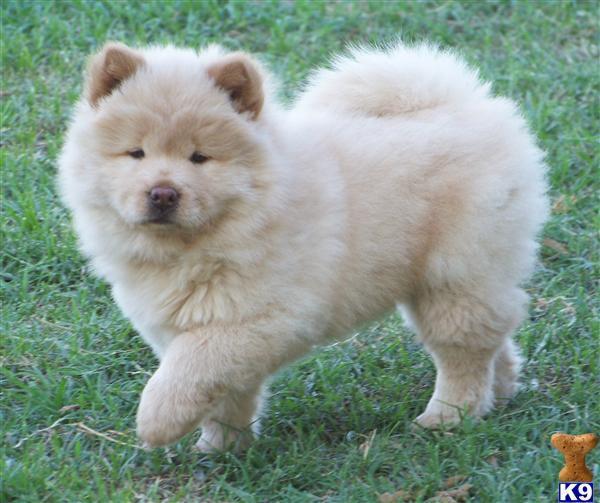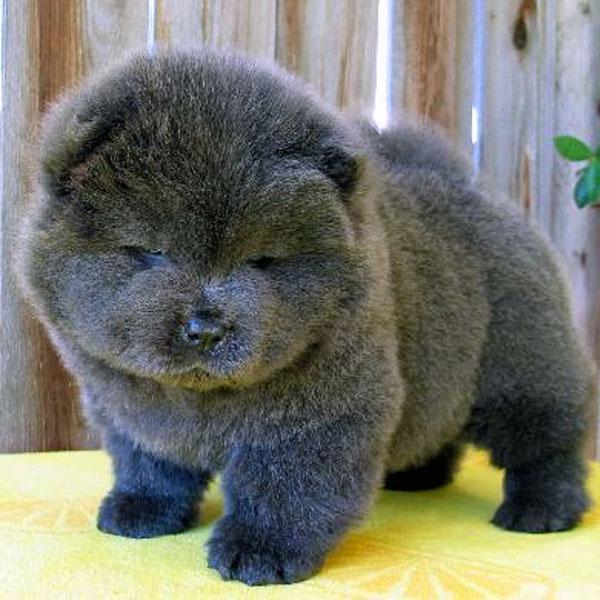The first image is the image on the left, the second image is the image on the right. For the images displayed, is the sentence "Only one dog is not in the grass." factually correct? Answer yes or no. Yes. The first image is the image on the left, the second image is the image on the right. Examine the images to the left and right. Is the description "One dog has his left front paw off the ground." accurate? Answer yes or no. Yes. 